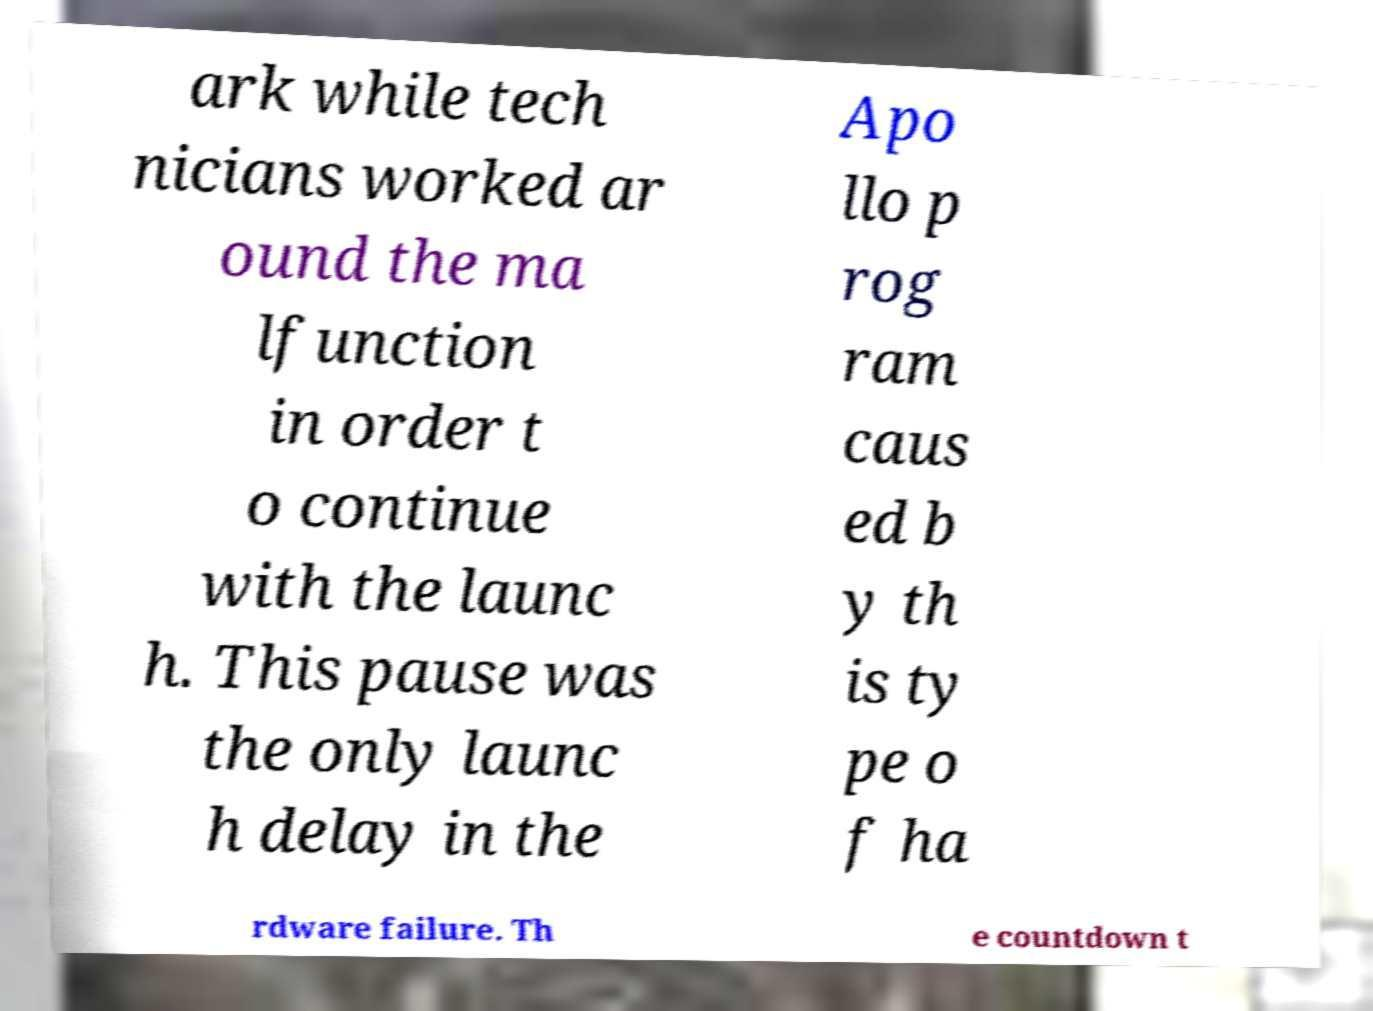I need the written content from this picture converted into text. Can you do that? ark while tech nicians worked ar ound the ma lfunction in order t o continue with the launc h. This pause was the only launc h delay in the Apo llo p rog ram caus ed b y th is ty pe o f ha rdware failure. Th e countdown t 